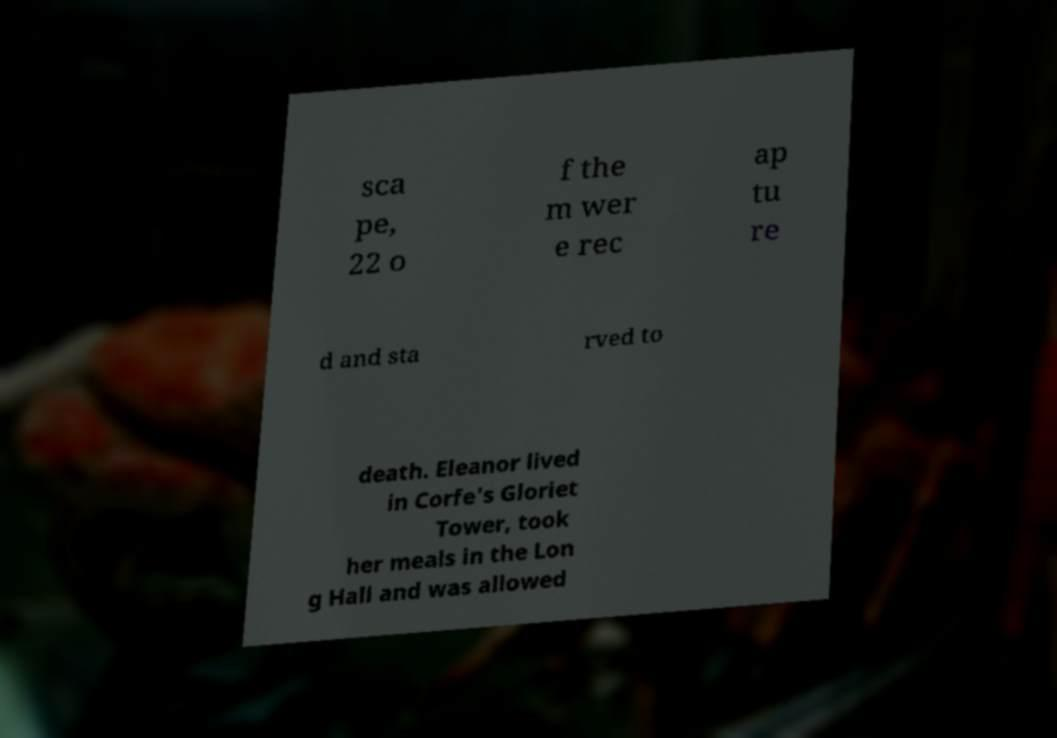Could you assist in decoding the text presented in this image and type it out clearly? sca pe, 22 o f the m wer e rec ap tu re d and sta rved to death. Eleanor lived in Corfe's Gloriet Tower, took her meals in the Lon g Hall and was allowed 